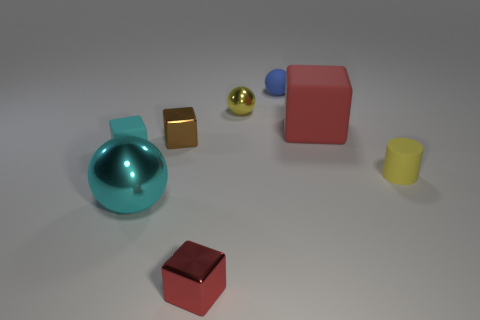How many cylinders are either small metal objects or big cyan shiny objects?
Provide a succinct answer. 0. How many tiny rubber objects are to the left of the matte cylinder and on the right side of the tiny red block?
Your response must be concise. 1. There is a yellow matte thing; is its size the same as the block that is on the left side of the brown block?
Your answer should be compact. Yes. There is a block in front of the tiny rubber thing right of the small rubber sphere; are there any yellow shiny balls right of it?
Give a very brief answer. Yes. There is a yellow object in front of the metallic thing that is behind the big block; what is its material?
Your answer should be compact. Rubber. There is a thing that is right of the tiny yellow metallic object and in front of the brown metal thing; what is its material?
Provide a short and direct response. Rubber. Are there any other big rubber things that have the same shape as the brown object?
Your answer should be compact. Yes. Is there a red object to the left of the small yellow object that is behind the yellow rubber cylinder?
Offer a very short reply. Yes. What number of large cyan cubes have the same material as the yellow ball?
Provide a succinct answer. 0. Are there any large cyan cubes?
Your answer should be compact. No. 